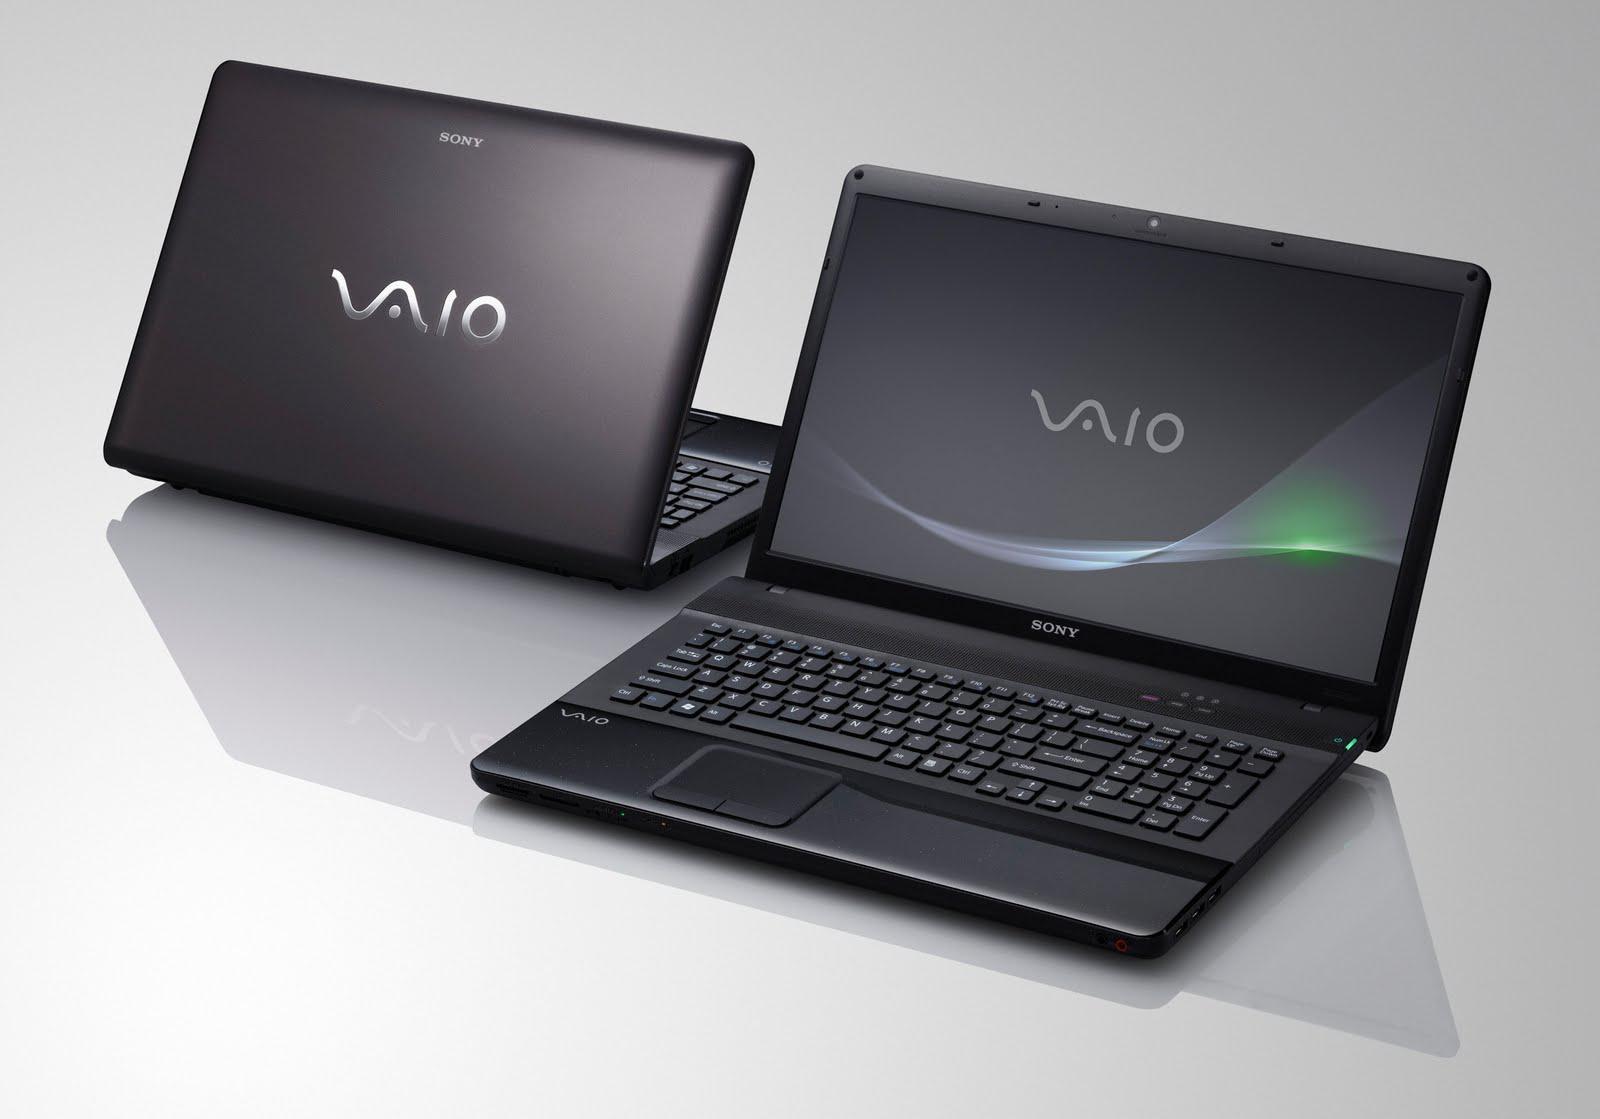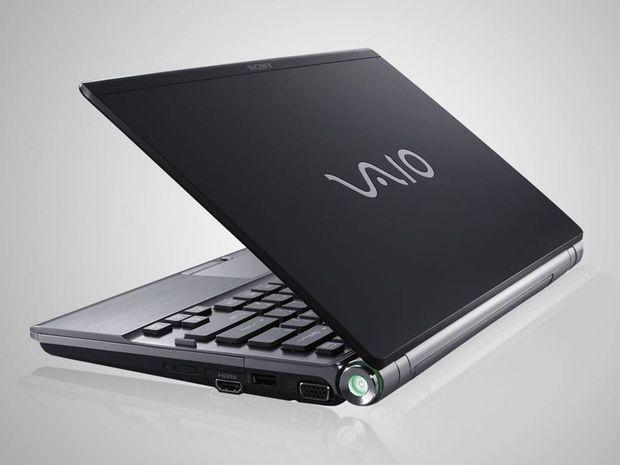The first image is the image on the left, the second image is the image on the right. Given the left and right images, does the statement "There are three laptops, and every visible screen is black." hold true? Answer yes or no. No. The first image is the image on the left, the second image is the image on the right. Analyze the images presented: Is the assertion "There is exactly two lap tops in the left image." valid? Answer yes or no. Yes. 